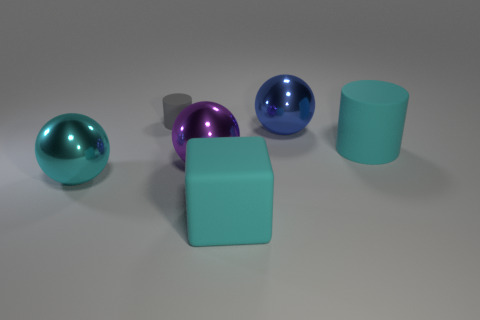What shape is the thing that is behind the cyan cylinder and to the right of the block?
Your response must be concise. Sphere. There is a cyan matte block right of the tiny cylinder; how big is it?
Ensure brevity in your answer.  Large. Is the size of the blue ball the same as the gray cylinder?
Your answer should be very brief. No. Is the number of large matte cubes that are to the left of the gray object less than the number of rubber cylinders that are to the left of the large purple shiny object?
Provide a succinct answer. Yes. What size is the thing that is both behind the big cyan matte cylinder and to the left of the purple metallic sphere?
Keep it short and to the point. Small. There is a cyan thing on the left side of the matte cylinder on the left side of the cyan rubber cylinder; is there a large blue shiny sphere that is left of it?
Ensure brevity in your answer.  No. Are there any big purple spheres?
Keep it short and to the point. Yes. Are there more cyan matte objects behind the big matte block than gray cylinders that are to the right of the small gray matte thing?
Give a very brief answer. Yes. There is a gray cylinder that is the same material as the big cube; what is its size?
Provide a short and direct response. Small. There is a matte cylinder that is on the right side of the large matte object that is on the left side of the big cyan object behind the cyan sphere; what size is it?
Your answer should be compact. Large. 